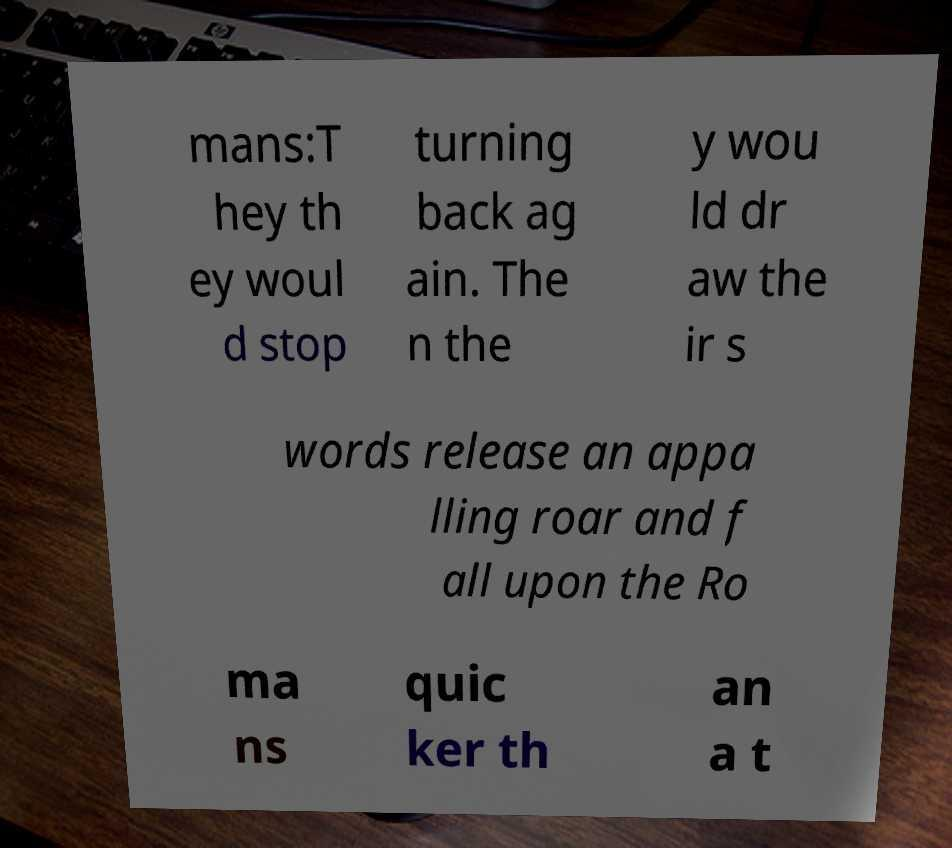What messages or text are displayed in this image? I need them in a readable, typed format. mans:T hey th ey woul d stop turning back ag ain. The n the y wou ld dr aw the ir s words release an appa lling roar and f all upon the Ro ma ns quic ker th an a t 